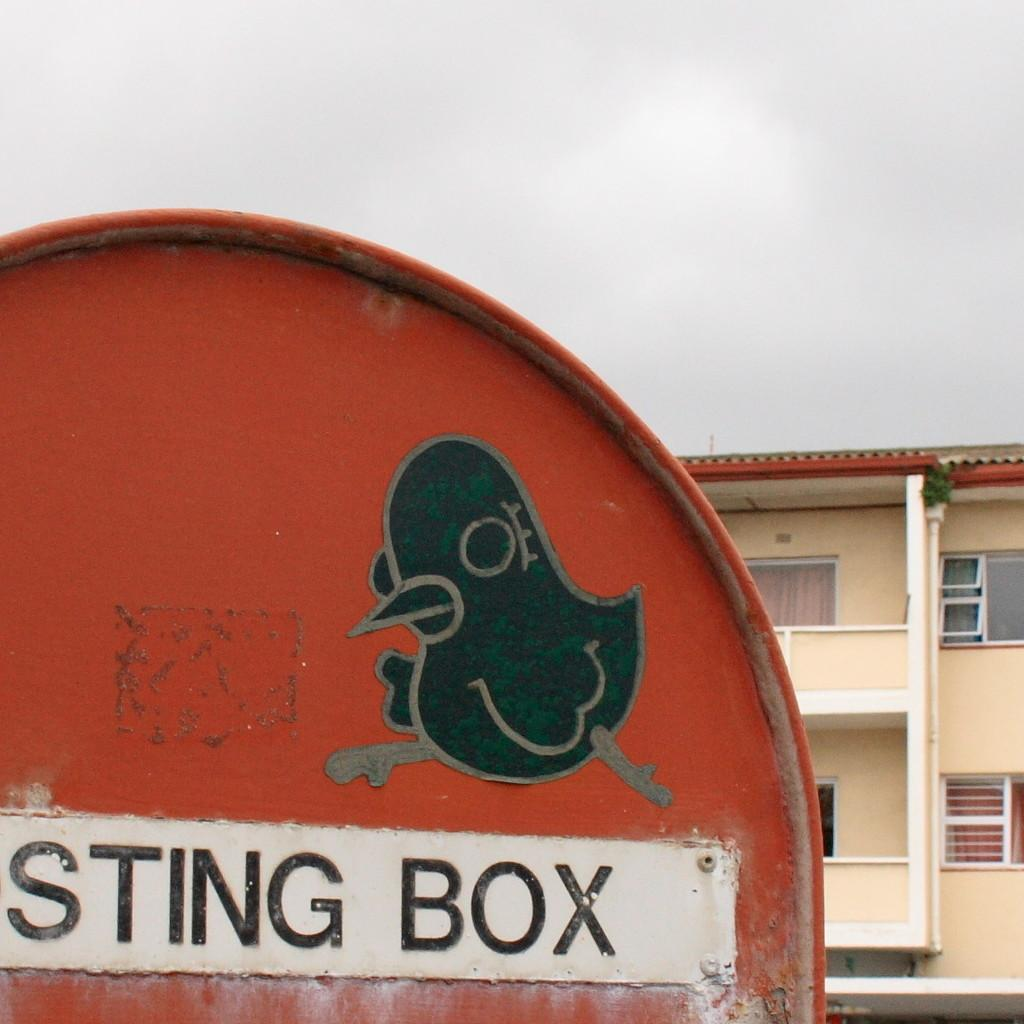What is the main object in the image? There is a board in the image. What structure can be seen in the image? There is a building in the image. What can be seen in the distance in the image? The sky is visible in the background of the image. What type of chalk is being used to write on the board in the image? There is no chalk visible in the image, and no writing is shown on the board. 